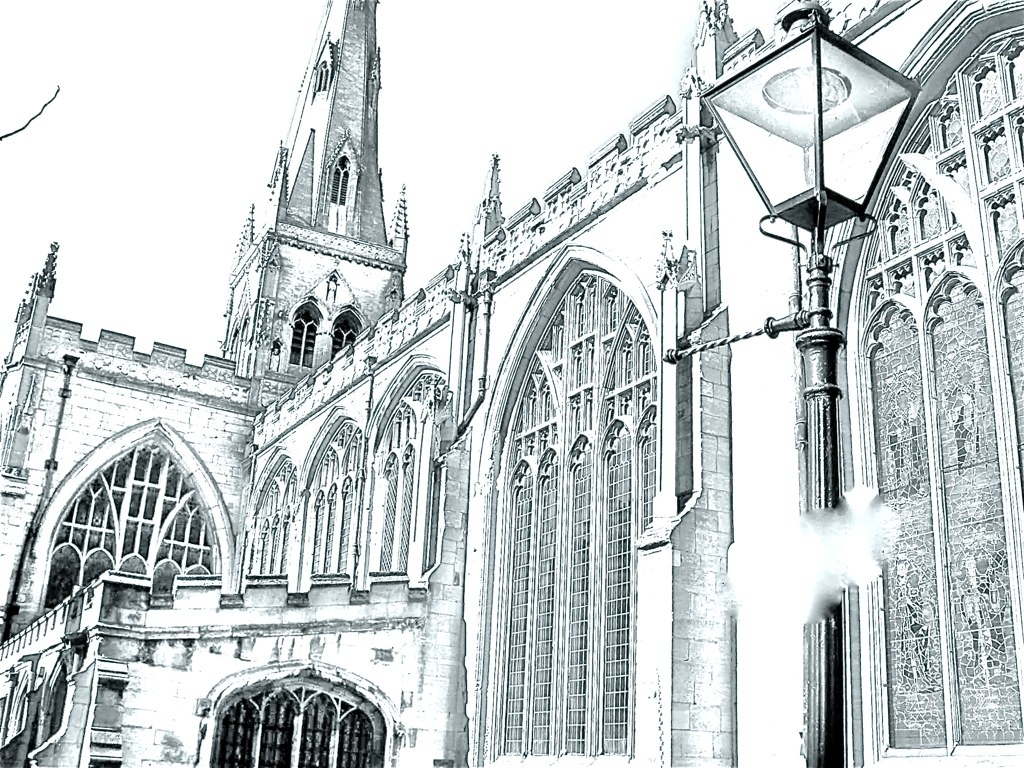How would you describe the image quality? The image appears to be overexposed, resulting in a loss of detail particularly in the brighter areas of the architecture and the sky. This diminishes the picture's dynamic range and contrast, which are essential for a visually appealing photograph. However, the composition is striking, featuring the gothic architectural elements of the building. 